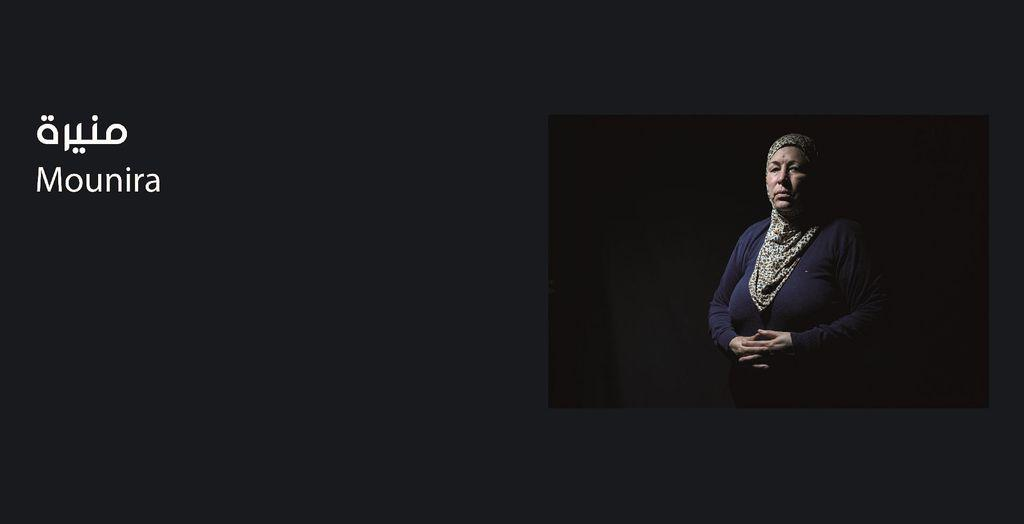Who is the main subject in the image? There is a woman in the image. What is the woman wearing? The woman is wearing a blue dress. Where is the woman located in the image? The woman is on the right side of the image. Can you read the woman's name in the image? The woman's name is on the left side of the poster. What type of hat is the woman wearing in the image? There is no hat visible in the image; the woman is wearing a blue dress. Can you describe the sidewalk in the image? There is no sidewalk present in the image; it features a woman on the right side of the image and a poster with her name on the left side. 